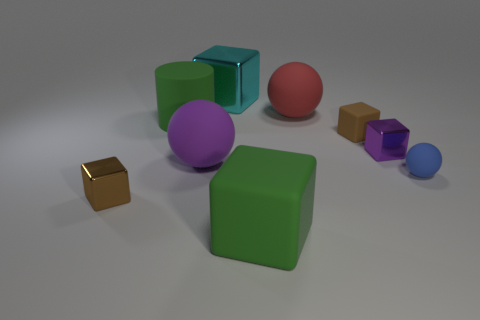Does the lighting in this image suggest a particular time of day or setting? The lighting in the image is soft and diffused, without harsh shadows or bright highlights, which suggests an artificial or controlled lighting environment rather than a natural setting. It does not indicate a specific time of day but is more reminiscent of studio lighting that is designed to evenly illuminate the objects. 